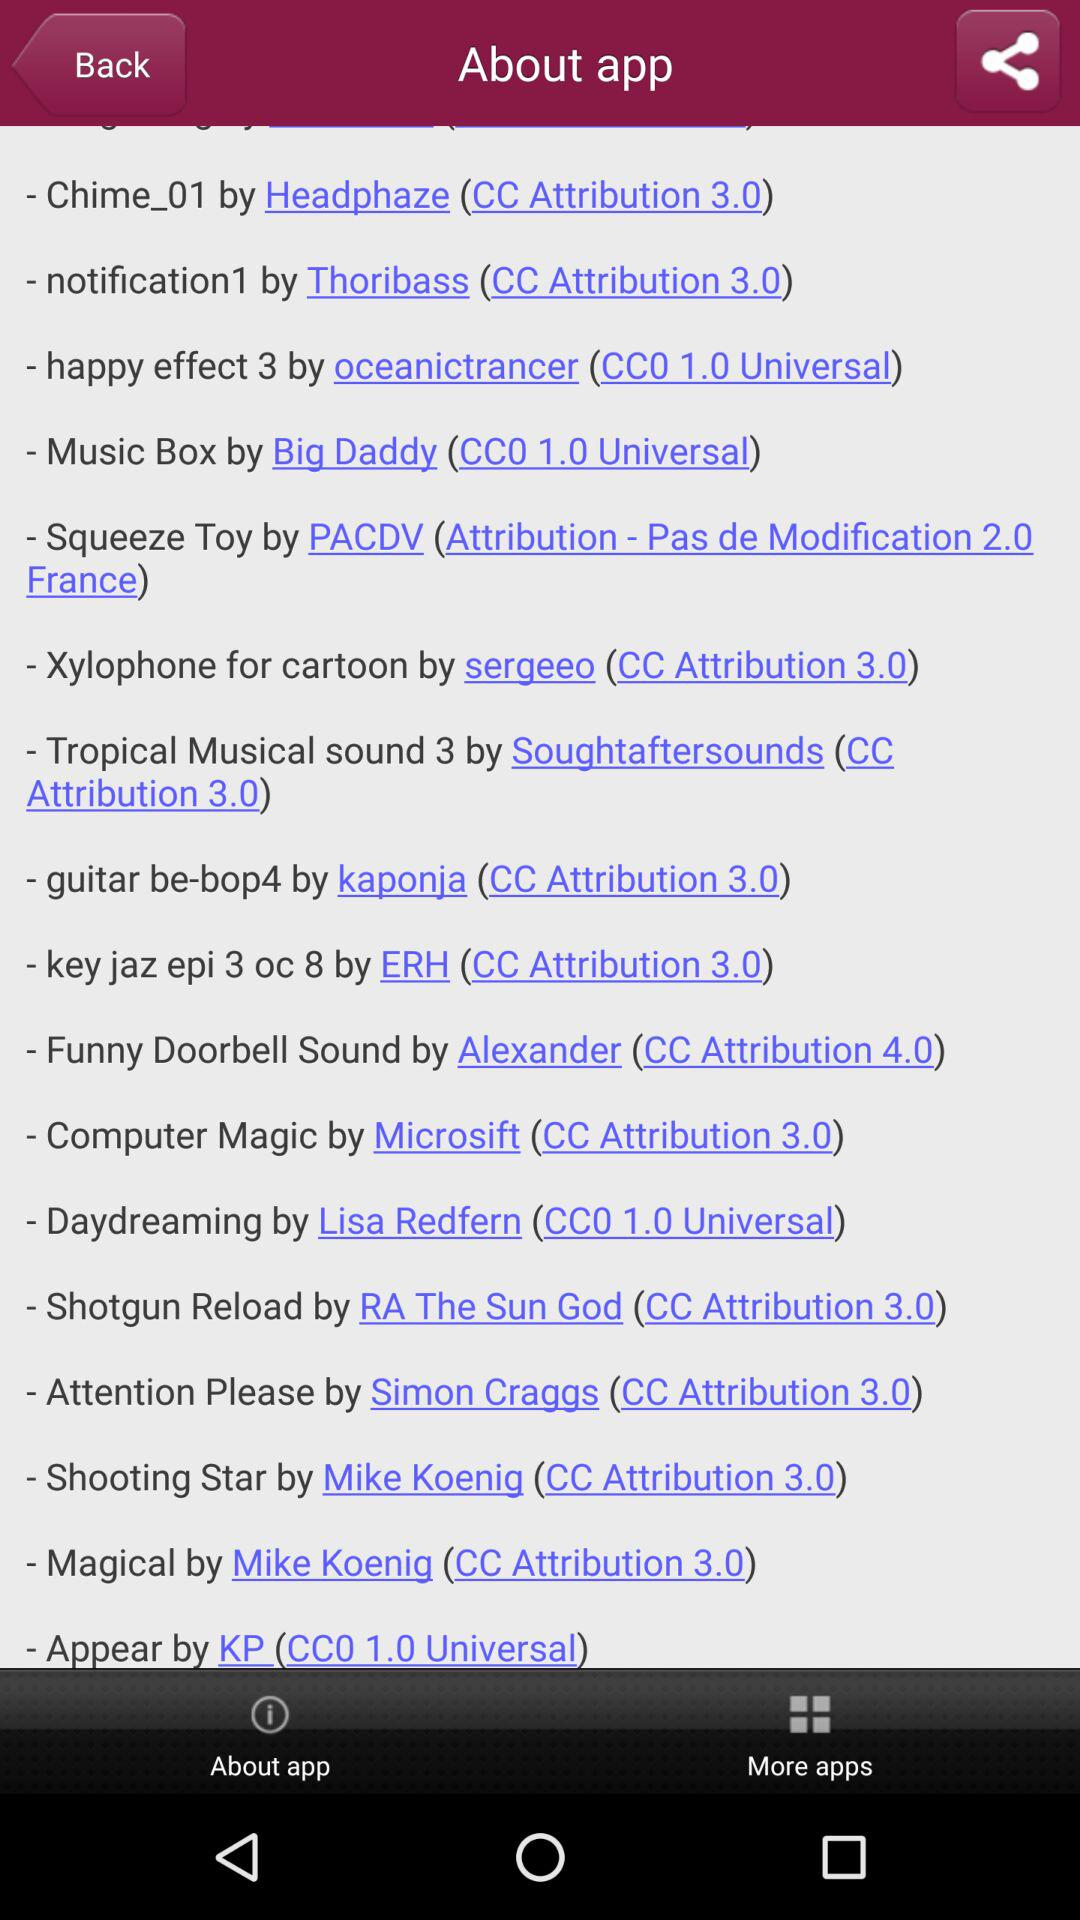By whom was the Shooting Star created? The Shooting Star was created by Mike Koenig. 